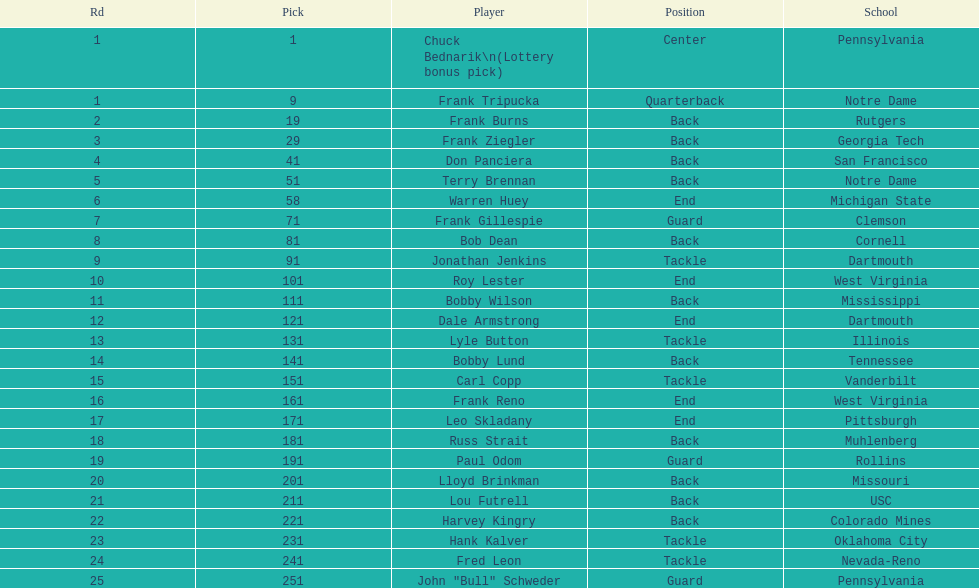Was chuck bednarik or frank tripucka the first draft pick? Chuck Bednarik. 